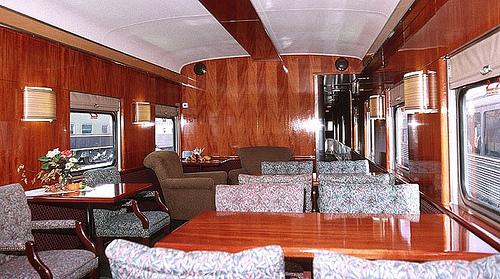What type of vehicle is this?
Answer briefly. Train. Are those flowers artificial?
Concise answer only. Yes. How many people can have a seat?
Be succinct. 12. 